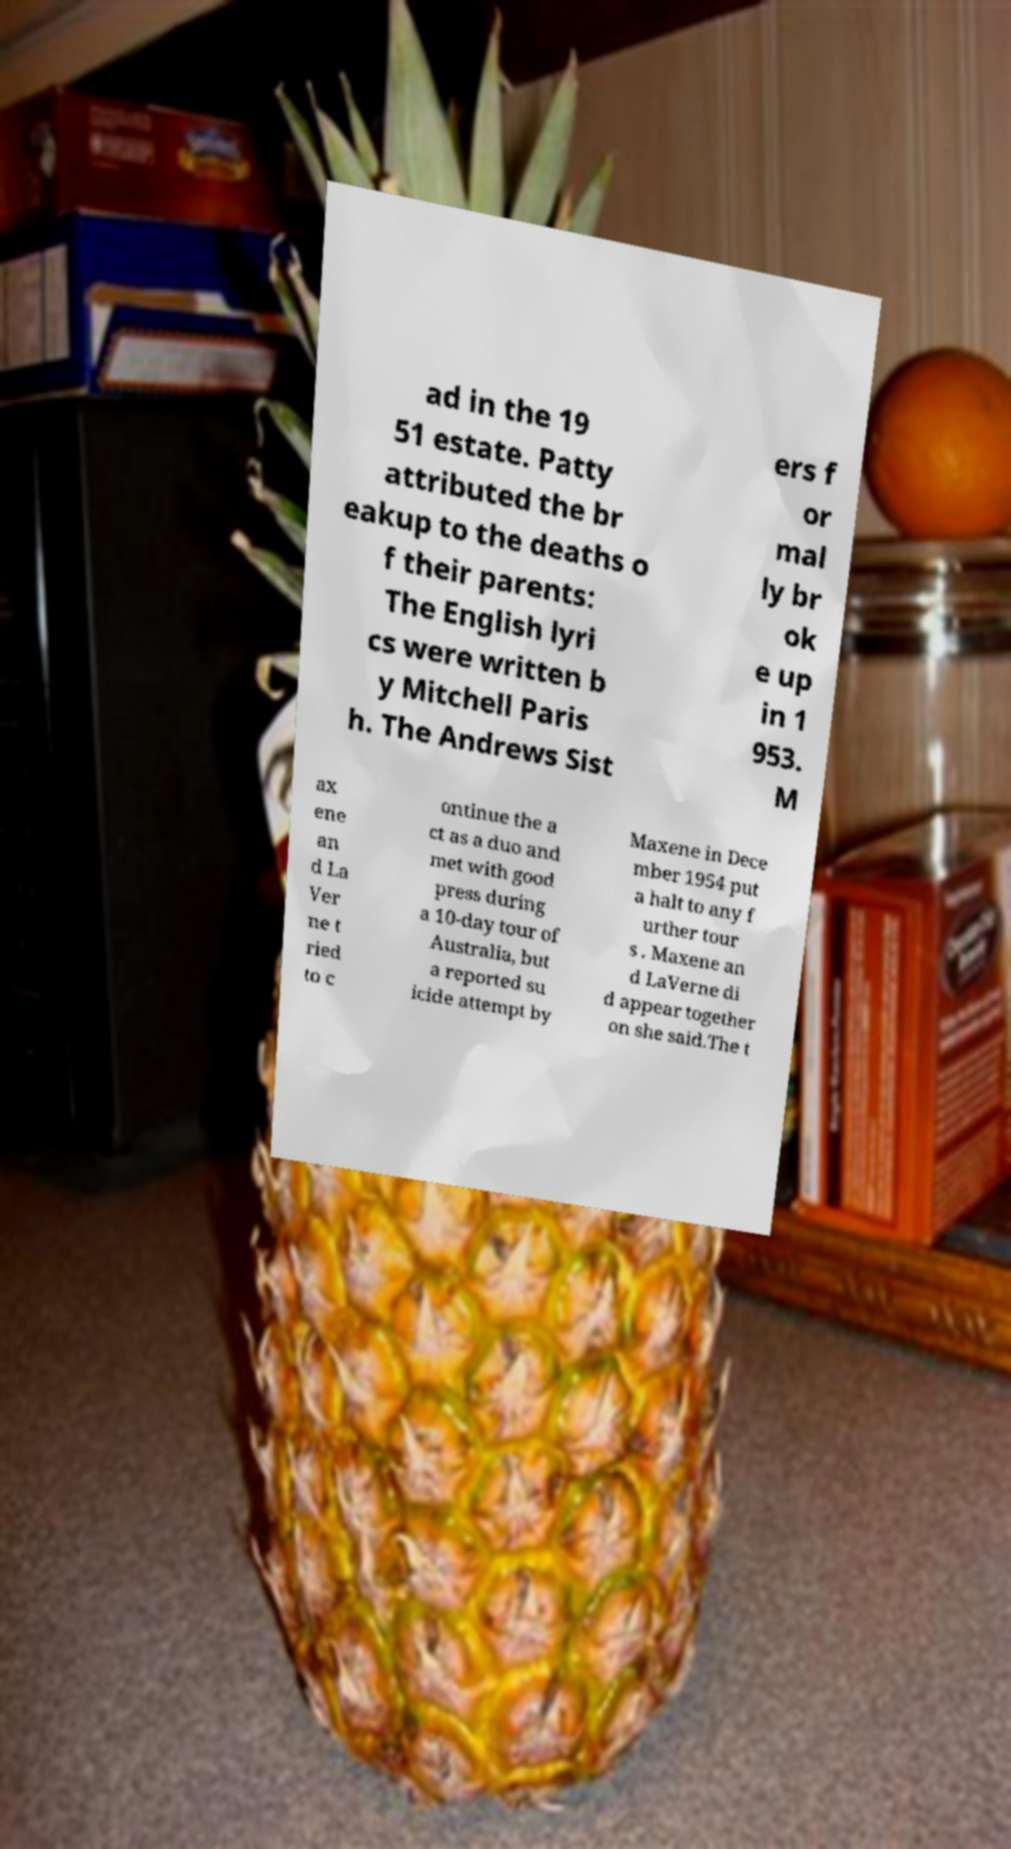Please read and relay the text visible in this image. What does it say? ad in the 19 51 estate. Patty attributed the br eakup to the deaths o f their parents: The English lyri cs were written b y Mitchell Paris h. The Andrews Sist ers f or mal ly br ok e up in 1 953. M ax ene an d La Ver ne t ried to c ontinue the a ct as a duo and met with good press during a 10-day tour of Australia, but a reported su icide attempt by Maxene in Dece mber 1954 put a halt to any f urther tour s . Maxene an d LaVerne di d appear together on she said.The t 